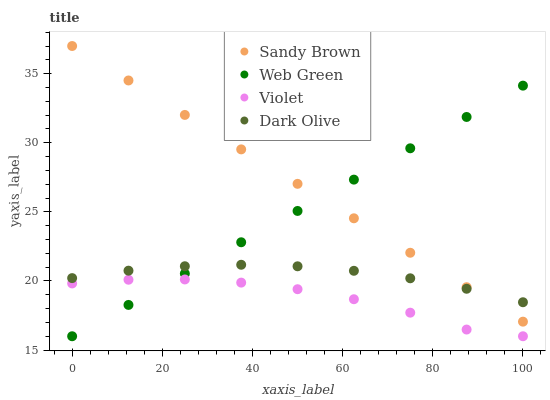Does Violet have the minimum area under the curve?
Answer yes or no. Yes. Does Sandy Brown have the maximum area under the curve?
Answer yes or no. Yes. Does Web Green have the minimum area under the curve?
Answer yes or no. No. Does Web Green have the maximum area under the curve?
Answer yes or no. No. Is Sandy Brown the smoothest?
Answer yes or no. Yes. Is Violet the roughest?
Answer yes or no. Yes. Is Web Green the smoothest?
Answer yes or no. No. Is Web Green the roughest?
Answer yes or no. No. Does Web Green have the lowest value?
Answer yes or no. Yes. Does Sandy Brown have the lowest value?
Answer yes or no. No. Does Sandy Brown have the highest value?
Answer yes or no. Yes. Does Web Green have the highest value?
Answer yes or no. No. Is Violet less than Dark Olive?
Answer yes or no. Yes. Is Sandy Brown greater than Violet?
Answer yes or no. Yes. Does Web Green intersect Dark Olive?
Answer yes or no. Yes. Is Web Green less than Dark Olive?
Answer yes or no. No. Is Web Green greater than Dark Olive?
Answer yes or no. No. Does Violet intersect Dark Olive?
Answer yes or no. No. 